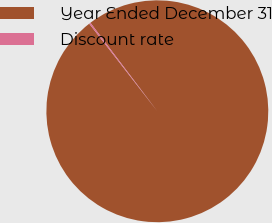<chart> <loc_0><loc_0><loc_500><loc_500><pie_chart><fcel>Year Ended December 31<fcel>Discount rate<nl><fcel>99.78%<fcel>0.22%<nl></chart> 